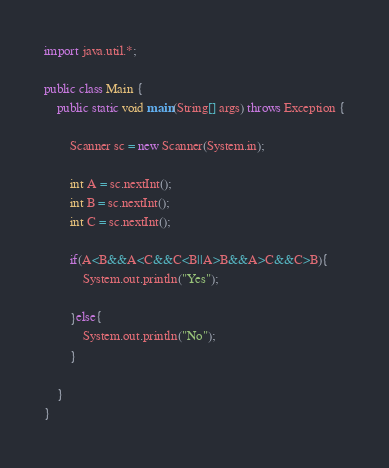<code> <loc_0><loc_0><loc_500><loc_500><_Java_>import java.util.*;

public class Main {
    public static void main(String[] args) throws Exception {
        
        Scanner sc = new Scanner(System.in);
        
        int A = sc.nextInt();
        int B = sc.nextInt();
        int C = sc.nextInt();
        
        if(A<B&&A<C&&C<B||A>B&&A>C&&C>B){
            System.out.println("Yes");
            
        }else{
            System.out.println("No");
        }
        
    }
}
</code> 